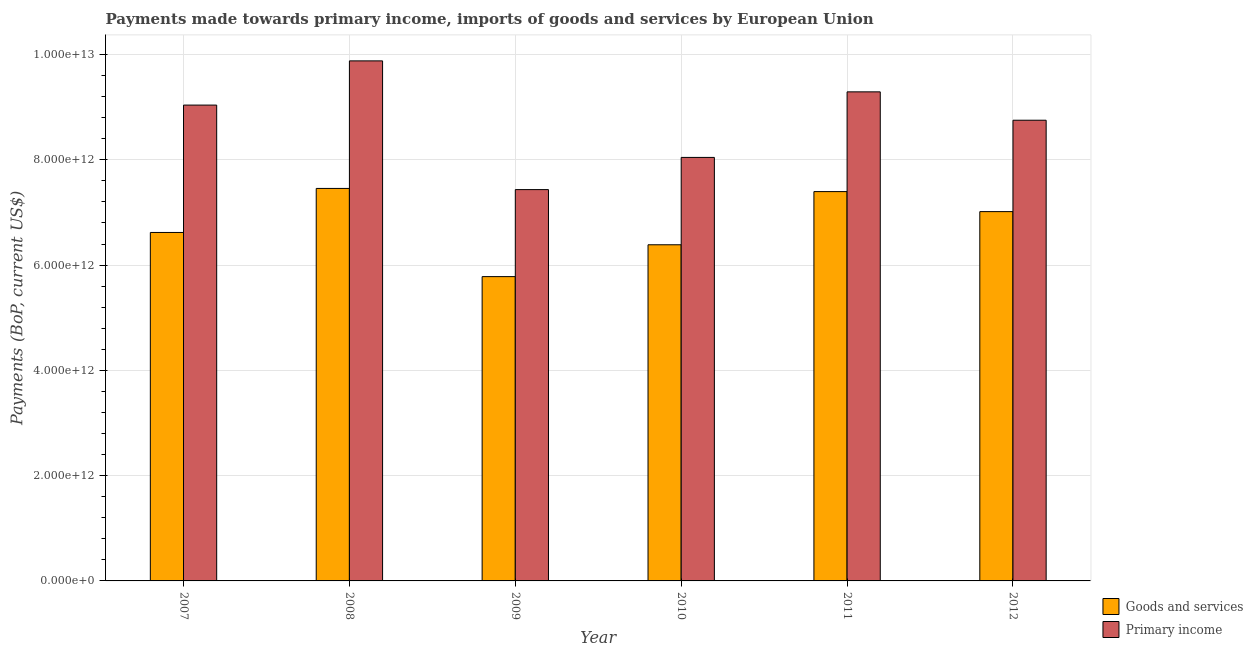How many groups of bars are there?
Offer a very short reply. 6. Are the number of bars per tick equal to the number of legend labels?
Offer a terse response. Yes. How many bars are there on the 4th tick from the right?
Provide a short and direct response. 2. In how many cases, is the number of bars for a given year not equal to the number of legend labels?
Your answer should be compact. 0. What is the payments made towards goods and services in 2011?
Offer a very short reply. 7.40e+12. Across all years, what is the maximum payments made towards primary income?
Keep it short and to the point. 9.88e+12. Across all years, what is the minimum payments made towards goods and services?
Offer a terse response. 5.78e+12. In which year was the payments made towards goods and services maximum?
Provide a succinct answer. 2008. In which year was the payments made towards primary income minimum?
Make the answer very short. 2009. What is the total payments made towards primary income in the graph?
Ensure brevity in your answer.  5.24e+13. What is the difference between the payments made towards primary income in 2007 and that in 2008?
Keep it short and to the point. -8.40e+11. What is the difference between the payments made towards primary income in 2010 and the payments made towards goods and services in 2007?
Offer a very short reply. -9.94e+11. What is the average payments made towards goods and services per year?
Your response must be concise. 6.78e+12. In how many years, is the payments made towards primary income greater than 6000000000000 US$?
Your answer should be compact. 6. What is the ratio of the payments made towards primary income in 2008 to that in 2011?
Give a very brief answer. 1.06. Is the payments made towards goods and services in 2011 less than that in 2012?
Your answer should be very brief. No. What is the difference between the highest and the second highest payments made towards goods and services?
Your answer should be very brief. 6.02e+1. What is the difference between the highest and the lowest payments made towards primary income?
Your response must be concise. 2.45e+12. In how many years, is the payments made towards primary income greater than the average payments made towards primary income taken over all years?
Ensure brevity in your answer.  4. Is the sum of the payments made towards primary income in 2007 and 2012 greater than the maximum payments made towards goods and services across all years?
Give a very brief answer. Yes. What does the 2nd bar from the left in 2007 represents?
Keep it short and to the point. Primary income. What does the 1st bar from the right in 2011 represents?
Offer a very short reply. Primary income. How many bars are there?
Give a very brief answer. 12. How many years are there in the graph?
Give a very brief answer. 6. What is the difference between two consecutive major ticks on the Y-axis?
Provide a succinct answer. 2.00e+12. Are the values on the major ticks of Y-axis written in scientific E-notation?
Provide a short and direct response. Yes. Does the graph contain grids?
Offer a very short reply. Yes. Where does the legend appear in the graph?
Offer a very short reply. Bottom right. How are the legend labels stacked?
Offer a terse response. Vertical. What is the title of the graph?
Offer a terse response. Payments made towards primary income, imports of goods and services by European Union. Does "Travel services" appear as one of the legend labels in the graph?
Offer a terse response. No. What is the label or title of the X-axis?
Your answer should be compact. Year. What is the label or title of the Y-axis?
Your answer should be very brief. Payments (BoP, current US$). What is the Payments (BoP, current US$) of Goods and services in 2007?
Give a very brief answer. 6.62e+12. What is the Payments (BoP, current US$) of Primary income in 2007?
Provide a succinct answer. 9.04e+12. What is the Payments (BoP, current US$) in Goods and services in 2008?
Provide a succinct answer. 7.46e+12. What is the Payments (BoP, current US$) in Primary income in 2008?
Offer a terse response. 9.88e+12. What is the Payments (BoP, current US$) in Goods and services in 2009?
Give a very brief answer. 5.78e+12. What is the Payments (BoP, current US$) of Primary income in 2009?
Your answer should be very brief. 7.43e+12. What is the Payments (BoP, current US$) in Goods and services in 2010?
Make the answer very short. 6.39e+12. What is the Payments (BoP, current US$) in Primary income in 2010?
Ensure brevity in your answer.  8.05e+12. What is the Payments (BoP, current US$) in Goods and services in 2011?
Provide a succinct answer. 7.40e+12. What is the Payments (BoP, current US$) of Primary income in 2011?
Provide a succinct answer. 9.29e+12. What is the Payments (BoP, current US$) of Goods and services in 2012?
Your answer should be compact. 7.02e+12. What is the Payments (BoP, current US$) of Primary income in 2012?
Your response must be concise. 8.75e+12. Across all years, what is the maximum Payments (BoP, current US$) of Goods and services?
Offer a very short reply. 7.46e+12. Across all years, what is the maximum Payments (BoP, current US$) in Primary income?
Your answer should be very brief. 9.88e+12. Across all years, what is the minimum Payments (BoP, current US$) in Goods and services?
Your answer should be very brief. 5.78e+12. Across all years, what is the minimum Payments (BoP, current US$) in Primary income?
Give a very brief answer. 7.43e+12. What is the total Payments (BoP, current US$) of Goods and services in the graph?
Ensure brevity in your answer.  4.07e+13. What is the total Payments (BoP, current US$) of Primary income in the graph?
Give a very brief answer. 5.24e+13. What is the difference between the Payments (BoP, current US$) in Goods and services in 2007 and that in 2008?
Offer a very short reply. -8.37e+11. What is the difference between the Payments (BoP, current US$) in Primary income in 2007 and that in 2008?
Provide a short and direct response. -8.40e+11. What is the difference between the Payments (BoP, current US$) in Goods and services in 2007 and that in 2009?
Your response must be concise. 8.39e+11. What is the difference between the Payments (BoP, current US$) of Primary income in 2007 and that in 2009?
Keep it short and to the point. 1.61e+12. What is the difference between the Payments (BoP, current US$) of Goods and services in 2007 and that in 2010?
Make the answer very short. 2.34e+11. What is the difference between the Payments (BoP, current US$) in Primary income in 2007 and that in 2010?
Your answer should be compact. 9.94e+11. What is the difference between the Payments (BoP, current US$) of Goods and services in 2007 and that in 2011?
Your response must be concise. -7.76e+11. What is the difference between the Payments (BoP, current US$) of Primary income in 2007 and that in 2011?
Ensure brevity in your answer.  -2.51e+11. What is the difference between the Payments (BoP, current US$) in Goods and services in 2007 and that in 2012?
Keep it short and to the point. -3.96e+11. What is the difference between the Payments (BoP, current US$) in Primary income in 2007 and that in 2012?
Keep it short and to the point. 2.87e+11. What is the difference between the Payments (BoP, current US$) of Goods and services in 2008 and that in 2009?
Offer a very short reply. 1.68e+12. What is the difference between the Payments (BoP, current US$) of Primary income in 2008 and that in 2009?
Offer a very short reply. 2.45e+12. What is the difference between the Payments (BoP, current US$) of Goods and services in 2008 and that in 2010?
Keep it short and to the point. 1.07e+12. What is the difference between the Payments (BoP, current US$) in Primary income in 2008 and that in 2010?
Keep it short and to the point. 1.83e+12. What is the difference between the Payments (BoP, current US$) in Goods and services in 2008 and that in 2011?
Your answer should be very brief. 6.02e+1. What is the difference between the Payments (BoP, current US$) of Primary income in 2008 and that in 2011?
Offer a terse response. 5.89e+11. What is the difference between the Payments (BoP, current US$) of Goods and services in 2008 and that in 2012?
Ensure brevity in your answer.  4.41e+11. What is the difference between the Payments (BoP, current US$) of Primary income in 2008 and that in 2012?
Your response must be concise. 1.13e+12. What is the difference between the Payments (BoP, current US$) in Goods and services in 2009 and that in 2010?
Your response must be concise. -6.05e+11. What is the difference between the Payments (BoP, current US$) of Primary income in 2009 and that in 2010?
Ensure brevity in your answer.  -6.12e+11. What is the difference between the Payments (BoP, current US$) of Goods and services in 2009 and that in 2011?
Offer a very short reply. -1.62e+12. What is the difference between the Payments (BoP, current US$) in Primary income in 2009 and that in 2011?
Offer a very short reply. -1.86e+12. What is the difference between the Payments (BoP, current US$) in Goods and services in 2009 and that in 2012?
Provide a succinct answer. -1.23e+12. What is the difference between the Payments (BoP, current US$) in Primary income in 2009 and that in 2012?
Keep it short and to the point. -1.32e+12. What is the difference between the Payments (BoP, current US$) in Goods and services in 2010 and that in 2011?
Keep it short and to the point. -1.01e+12. What is the difference between the Payments (BoP, current US$) of Primary income in 2010 and that in 2011?
Your answer should be very brief. -1.25e+12. What is the difference between the Payments (BoP, current US$) in Goods and services in 2010 and that in 2012?
Offer a very short reply. -6.30e+11. What is the difference between the Payments (BoP, current US$) in Primary income in 2010 and that in 2012?
Your answer should be very brief. -7.07e+11. What is the difference between the Payments (BoP, current US$) in Goods and services in 2011 and that in 2012?
Offer a very short reply. 3.80e+11. What is the difference between the Payments (BoP, current US$) of Primary income in 2011 and that in 2012?
Your answer should be compact. 5.39e+11. What is the difference between the Payments (BoP, current US$) in Goods and services in 2007 and the Payments (BoP, current US$) in Primary income in 2008?
Provide a succinct answer. -3.26e+12. What is the difference between the Payments (BoP, current US$) of Goods and services in 2007 and the Payments (BoP, current US$) of Primary income in 2009?
Give a very brief answer. -8.14e+11. What is the difference between the Payments (BoP, current US$) of Goods and services in 2007 and the Payments (BoP, current US$) of Primary income in 2010?
Provide a short and direct response. -1.43e+12. What is the difference between the Payments (BoP, current US$) of Goods and services in 2007 and the Payments (BoP, current US$) of Primary income in 2011?
Your response must be concise. -2.67e+12. What is the difference between the Payments (BoP, current US$) in Goods and services in 2007 and the Payments (BoP, current US$) in Primary income in 2012?
Offer a terse response. -2.13e+12. What is the difference between the Payments (BoP, current US$) of Goods and services in 2008 and the Payments (BoP, current US$) of Primary income in 2009?
Your answer should be very brief. 2.24e+1. What is the difference between the Payments (BoP, current US$) in Goods and services in 2008 and the Payments (BoP, current US$) in Primary income in 2010?
Give a very brief answer. -5.89e+11. What is the difference between the Payments (BoP, current US$) of Goods and services in 2008 and the Payments (BoP, current US$) of Primary income in 2011?
Provide a succinct answer. -1.83e+12. What is the difference between the Payments (BoP, current US$) of Goods and services in 2008 and the Payments (BoP, current US$) of Primary income in 2012?
Keep it short and to the point. -1.30e+12. What is the difference between the Payments (BoP, current US$) of Goods and services in 2009 and the Payments (BoP, current US$) of Primary income in 2010?
Your answer should be compact. -2.26e+12. What is the difference between the Payments (BoP, current US$) in Goods and services in 2009 and the Payments (BoP, current US$) in Primary income in 2011?
Offer a terse response. -3.51e+12. What is the difference between the Payments (BoP, current US$) in Goods and services in 2009 and the Payments (BoP, current US$) in Primary income in 2012?
Provide a succinct answer. -2.97e+12. What is the difference between the Payments (BoP, current US$) of Goods and services in 2010 and the Payments (BoP, current US$) of Primary income in 2011?
Ensure brevity in your answer.  -2.91e+12. What is the difference between the Payments (BoP, current US$) of Goods and services in 2010 and the Payments (BoP, current US$) of Primary income in 2012?
Provide a short and direct response. -2.37e+12. What is the difference between the Payments (BoP, current US$) of Goods and services in 2011 and the Payments (BoP, current US$) of Primary income in 2012?
Ensure brevity in your answer.  -1.36e+12. What is the average Payments (BoP, current US$) in Goods and services per year?
Keep it short and to the point. 6.78e+12. What is the average Payments (BoP, current US$) in Primary income per year?
Ensure brevity in your answer.  8.74e+12. In the year 2007, what is the difference between the Payments (BoP, current US$) in Goods and services and Payments (BoP, current US$) in Primary income?
Offer a terse response. -2.42e+12. In the year 2008, what is the difference between the Payments (BoP, current US$) in Goods and services and Payments (BoP, current US$) in Primary income?
Ensure brevity in your answer.  -2.42e+12. In the year 2009, what is the difference between the Payments (BoP, current US$) in Goods and services and Payments (BoP, current US$) in Primary income?
Make the answer very short. -1.65e+12. In the year 2010, what is the difference between the Payments (BoP, current US$) of Goods and services and Payments (BoP, current US$) of Primary income?
Your answer should be very brief. -1.66e+12. In the year 2011, what is the difference between the Payments (BoP, current US$) of Goods and services and Payments (BoP, current US$) of Primary income?
Your answer should be very brief. -1.89e+12. In the year 2012, what is the difference between the Payments (BoP, current US$) in Goods and services and Payments (BoP, current US$) in Primary income?
Your answer should be very brief. -1.74e+12. What is the ratio of the Payments (BoP, current US$) of Goods and services in 2007 to that in 2008?
Provide a succinct answer. 0.89. What is the ratio of the Payments (BoP, current US$) in Primary income in 2007 to that in 2008?
Provide a short and direct response. 0.92. What is the ratio of the Payments (BoP, current US$) in Goods and services in 2007 to that in 2009?
Provide a short and direct response. 1.15. What is the ratio of the Payments (BoP, current US$) of Primary income in 2007 to that in 2009?
Keep it short and to the point. 1.22. What is the ratio of the Payments (BoP, current US$) of Goods and services in 2007 to that in 2010?
Provide a short and direct response. 1.04. What is the ratio of the Payments (BoP, current US$) in Primary income in 2007 to that in 2010?
Offer a terse response. 1.12. What is the ratio of the Payments (BoP, current US$) of Goods and services in 2007 to that in 2011?
Your response must be concise. 0.9. What is the ratio of the Payments (BoP, current US$) in Primary income in 2007 to that in 2011?
Give a very brief answer. 0.97. What is the ratio of the Payments (BoP, current US$) in Goods and services in 2007 to that in 2012?
Make the answer very short. 0.94. What is the ratio of the Payments (BoP, current US$) in Primary income in 2007 to that in 2012?
Provide a succinct answer. 1.03. What is the ratio of the Payments (BoP, current US$) of Goods and services in 2008 to that in 2009?
Provide a succinct answer. 1.29. What is the ratio of the Payments (BoP, current US$) of Primary income in 2008 to that in 2009?
Your answer should be very brief. 1.33. What is the ratio of the Payments (BoP, current US$) of Goods and services in 2008 to that in 2010?
Your response must be concise. 1.17. What is the ratio of the Payments (BoP, current US$) in Primary income in 2008 to that in 2010?
Your answer should be compact. 1.23. What is the ratio of the Payments (BoP, current US$) of Goods and services in 2008 to that in 2011?
Your answer should be compact. 1.01. What is the ratio of the Payments (BoP, current US$) of Primary income in 2008 to that in 2011?
Provide a succinct answer. 1.06. What is the ratio of the Payments (BoP, current US$) of Goods and services in 2008 to that in 2012?
Give a very brief answer. 1.06. What is the ratio of the Payments (BoP, current US$) of Primary income in 2008 to that in 2012?
Your response must be concise. 1.13. What is the ratio of the Payments (BoP, current US$) of Goods and services in 2009 to that in 2010?
Provide a short and direct response. 0.91. What is the ratio of the Payments (BoP, current US$) of Primary income in 2009 to that in 2010?
Your answer should be very brief. 0.92. What is the ratio of the Payments (BoP, current US$) of Goods and services in 2009 to that in 2011?
Make the answer very short. 0.78. What is the ratio of the Payments (BoP, current US$) in Primary income in 2009 to that in 2011?
Provide a short and direct response. 0.8. What is the ratio of the Payments (BoP, current US$) in Goods and services in 2009 to that in 2012?
Provide a succinct answer. 0.82. What is the ratio of the Payments (BoP, current US$) of Primary income in 2009 to that in 2012?
Provide a short and direct response. 0.85. What is the ratio of the Payments (BoP, current US$) of Goods and services in 2010 to that in 2011?
Keep it short and to the point. 0.86. What is the ratio of the Payments (BoP, current US$) of Primary income in 2010 to that in 2011?
Offer a very short reply. 0.87. What is the ratio of the Payments (BoP, current US$) of Goods and services in 2010 to that in 2012?
Your response must be concise. 0.91. What is the ratio of the Payments (BoP, current US$) in Primary income in 2010 to that in 2012?
Ensure brevity in your answer.  0.92. What is the ratio of the Payments (BoP, current US$) of Goods and services in 2011 to that in 2012?
Your response must be concise. 1.05. What is the ratio of the Payments (BoP, current US$) in Primary income in 2011 to that in 2012?
Your response must be concise. 1.06. What is the difference between the highest and the second highest Payments (BoP, current US$) in Goods and services?
Provide a short and direct response. 6.02e+1. What is the difference between the highest and the second highest Payments (BoP, current US$) of Primary income?
Your response must be concise. 5.89e+11. What is the difference between the highest and the lowest Payments (BoP, current US$) in Goods and services?
Your response must be concise. 1.68e+12. What is the difference between the highest and the lowest Payments (BoP, current US$) of Primary income?
Make the answer very short. 2.45e+12. 